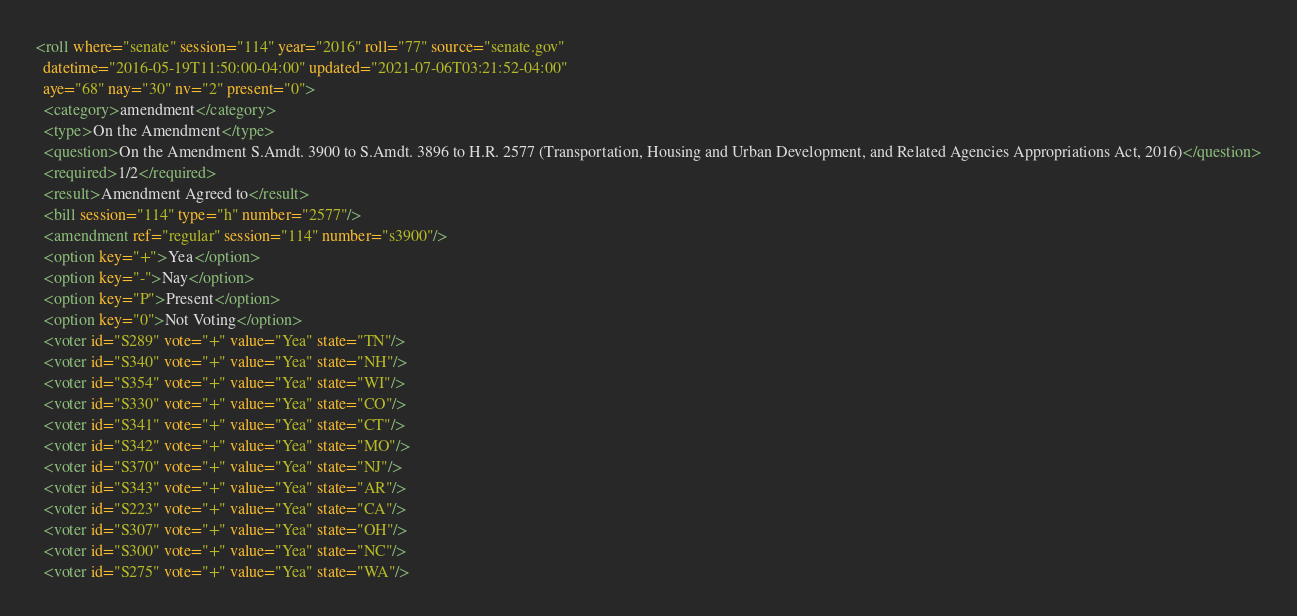Convert code to text. <code><loc_0><loc_0><loc_500><loc_500><_XML_><roll where="senate" session="114" year="2016" roll="77" source="senate.gov"
  datetime="2016-05-19T11:50:00-04:00" updated="2021-07-06T03:21:52-04:00"
  aye="68" nay="30" nv="2" present="0">
  <category>amendment</category>
  <type>On the Amendment</type>
  <question>On the Amendment S.Amdt. 3900 to S.Amdt. 3896 to H.R. 2577 (Transportation, Housing and Urban Development, and Related Agencies Appropriations Act, 2016)</question>
  <required>1/2</required>
  <result>Amendment Agreed to</result>
  <bill session="114" type="h" number="2577"/>
  <amendment ref="regular" session="114" number="s3900"/>
  <option key="+">Yea</option>
  <option key="-">Nay</option>
  <option key="P">Present</option>
  <option key="0">Not Voting</option>
  <voter id="S289" vote="+" value="Yea" state="TN"/>
  <voter id="S340" vote="+" value="Yea" state="NH"/>
  <voter id="S354" vote="+" value="Yea" state="WI"/>
  <voter id="S330" vote="+" value="Yea" state="CO"/>
  <voter id="S341" vote="+" value="Yea" state="CT"/>
  <voter id="S342" vote="+" value="Yea" state="MO"/>
  <voter id="S370" vote="+" value="Yea" state="NJ"/>
  <voter id="S343" vote="+" value="Yea" state="AR"/>
  <voter id="S223" vote="+" value="Yea" state="CA"/>
  <voter id="S307" vote="+" value="Yea" state="OH"/>
  <voter id="S300" vote="+" value="Yea" state="NC"/>
  <voter id="S275" vote="+" value="Yea" state="WA"/></code> 